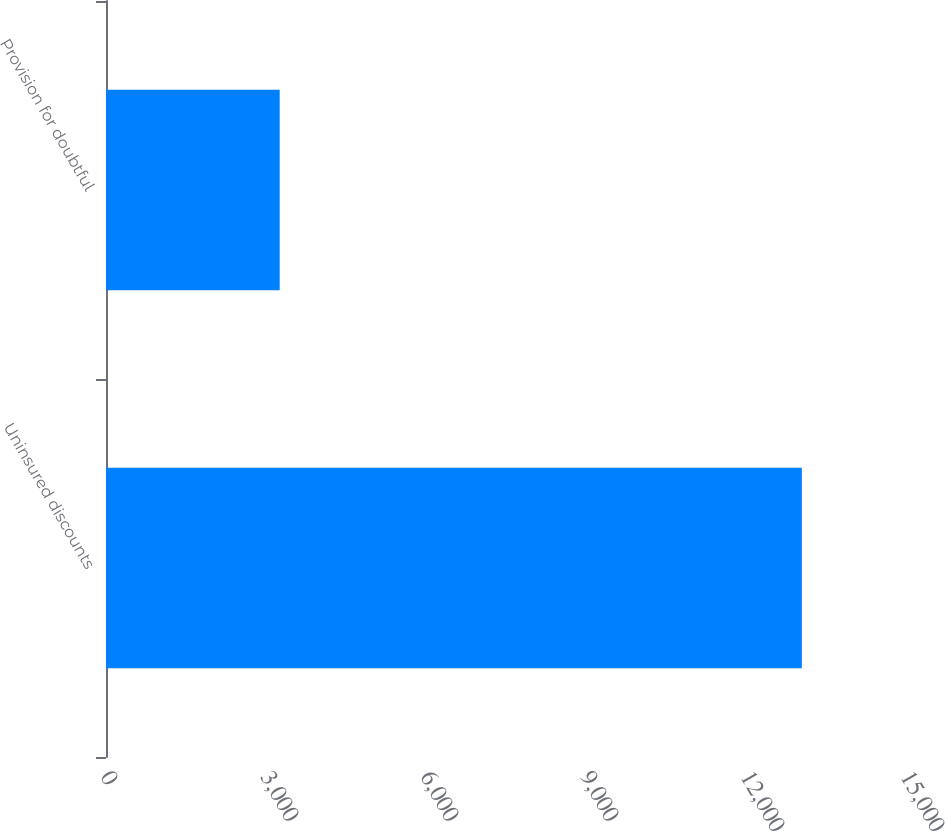Convert chart to OTSL. <chart><loc_0><loc_0><loc_500><loc_500><bar_chart><fcel>Uninsured discounts<fcel>Provision for doubtful<nl><fcel>13047<fcel>3257<nl></chart> 